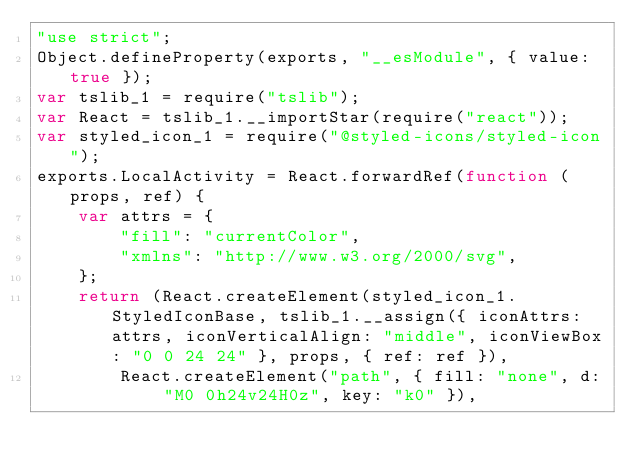Convert code to text. <code><loc_0><loc_0><loc_500><loc_500><_JavaScript_>"use strict";
Object.defineProperty(exports, "__esModule", { value: true });
var tslib_1 = require("tslib");
var React = tslib_1.__importStar(require("react"));
var styled_icon_1 = require("@styled-icons/styled-icon");
exports.LocalActivity = React.forwardRef(function (props, ref) {
    var attrs = {
        "fill": "currentColor",
        "xmlns": "http://www.w3.org/2000/svg",
    };
    return (React.createElement(styled_icon_1.StyledIconBase, tslib_1.__assign({ iconAttrs: attrs, iconVerticalAlign: "middle", iconViewBox: "0 0 24 24" }, props, { ref: ref }),
        React.createElement("path", { fill: "none", d: "M0 0h24v24H0z", key: "k0" }),</code> 